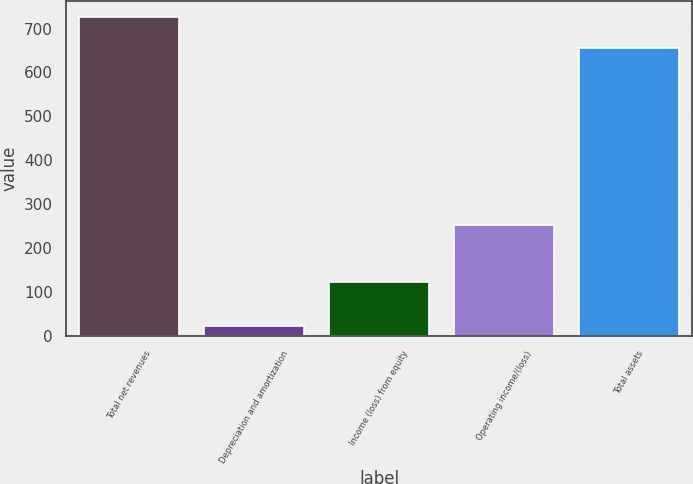<chart> <loc_0><loc_0><loc_500><loc_500><bar_chart><fcel>Total net revenues<fcel>Depreciation and amortization<fcel>Income (loss) from equity<fcel>Operating income/(loss)<fcel>Total assets<nl><fcel>726.42<fcel>23.2<fcel>122.4<fcel>253.5<fcel>656.6<nl></chart> 